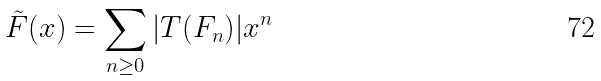Convert formula to latex. <formula><loc_0><loc_0><loc_500><loc_500>\tilde { F } ( x ) = \sum _ { n \geq 0 } | T ( F _ { n } ) | x ^ { n }</formula> 